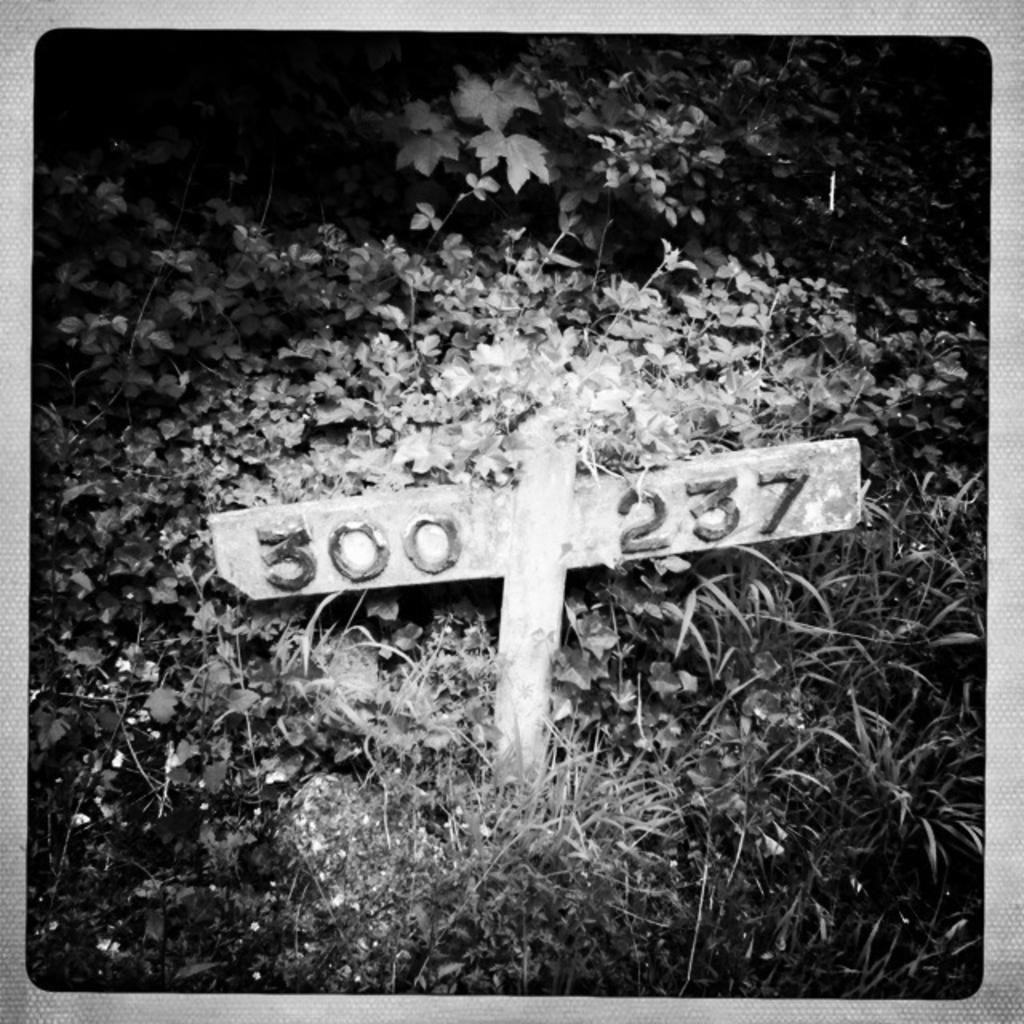What numbers on the wood?
Provide a succinct answer. 300 237. 